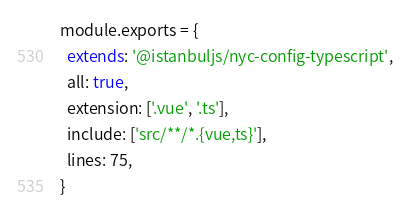Convert code to text. <code><loc_0><loc_0><loc_500><loc_500><_JavaScript_>module.exports = {
  extends: '@istanbuljs/nyc-config-typescript',
  all: true,
  extension: ['.vue', '.ts'],
  include: ['src/**/*.{vue,ts}'],
  lines: 75,
}
</code> 